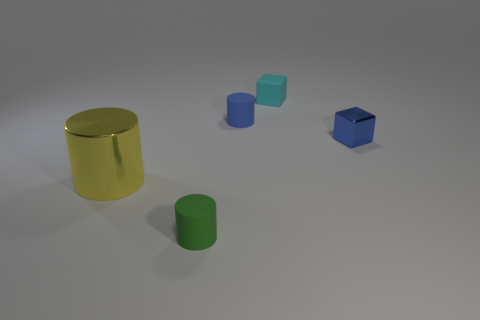If this image were part of a puzzle, what might be the challenge? If this image were part of a puzzle, the challenge might be to determine the correct sequence of these shapes based on size, color, or material properties. 